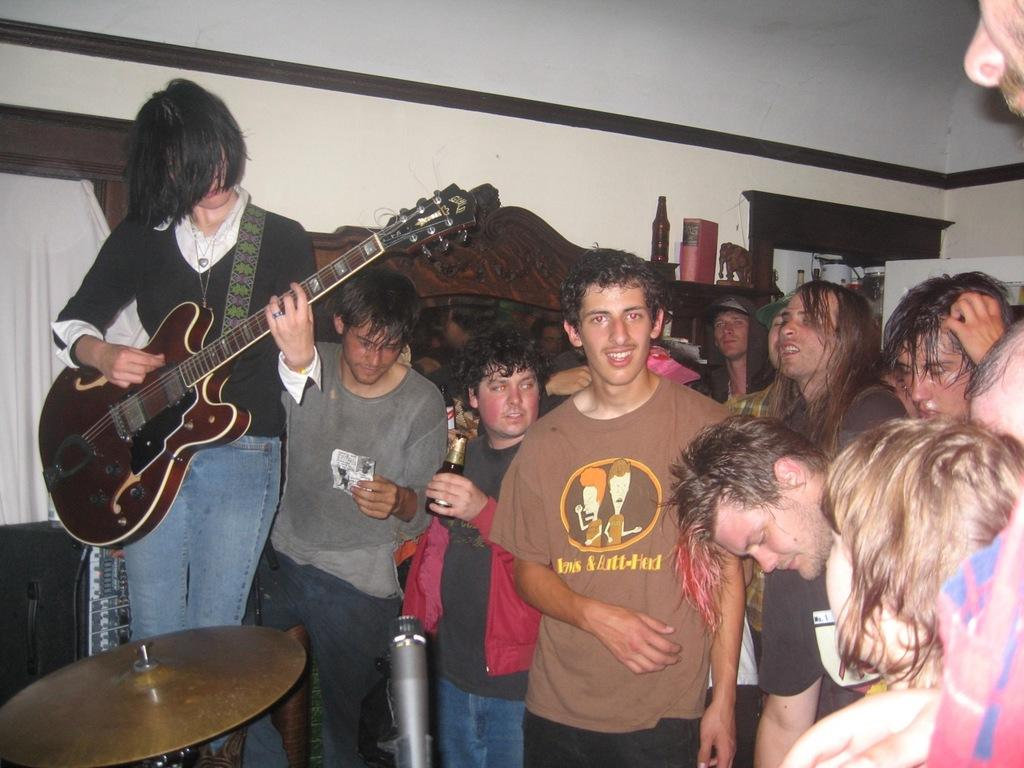What is happening in the image? There is a group of people standing in the image. What activity is one person engaged in? One person is playing a guitar. What object is another person holding? Another person is holding a bottle. What can be seen in the background of the image? There is a wall visible in the background of the image. What type of stem is being used to protest in the image? There is no stem or protest present in the image; it features a group of people with a guitar player and a person holding a bottle. 